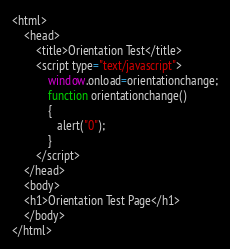Convert code to text. <code><loc_0><loc_0><loc_500><loc_500><_HTML_><html>
    <head>
        <title>Orientation Test</title>
        <script type="text/javascript">
            window.onload=orientationchange;
            function orientationchange()
            {
               alert("0");
            }
        </script>
    </head>
    <body>
    <h1>Orientation Test Page</h1>
    </body>
</html>
</code> 